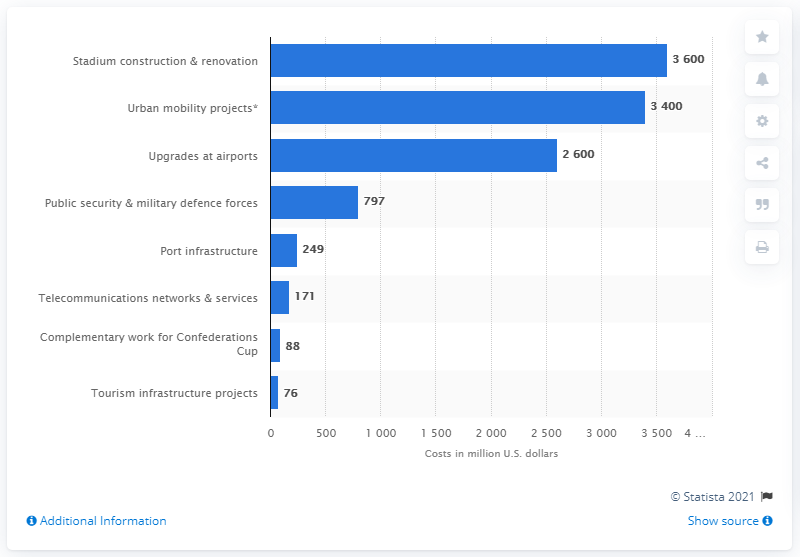Give some essential details in this illustration. The estimated cost of stadium construction and renovation is approximately $3,600. 